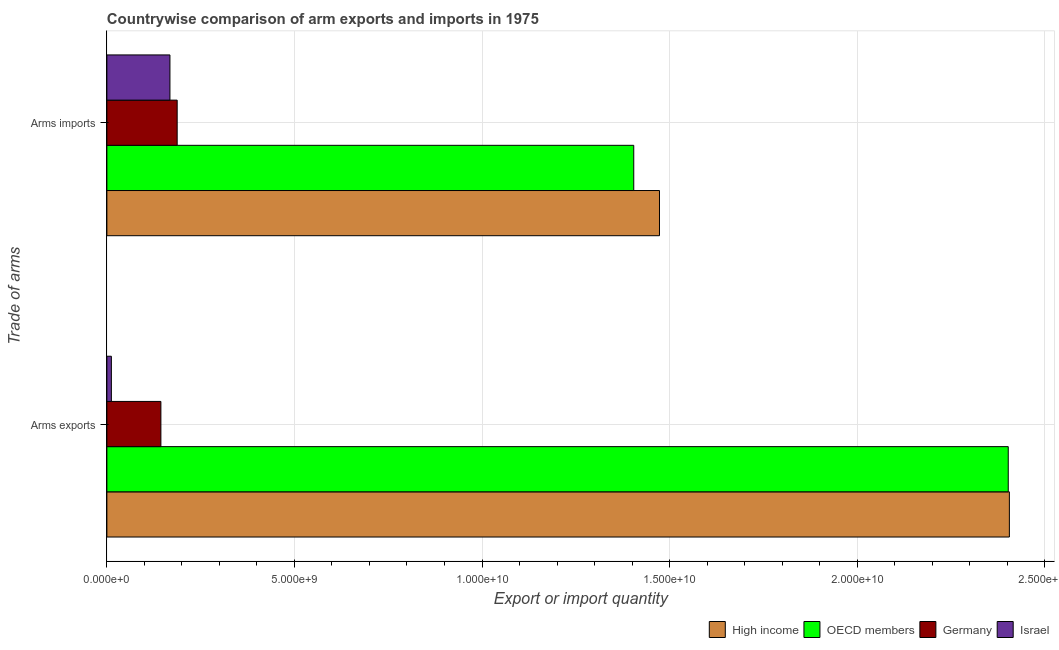How many groups of bars are there?
Offer a terse response. 2. What is the label of the 1st group of bars from the top?
Make the answer very short. Arms imports. What is the arms imports in Israel?
Offer a very short reply. 1.68e+09. Across all countries, what is the maximum arms exports?
Your answer should be compact. 2.41e+1. Across all countries, what is the minimum arms imports?
Offer a terse response. 1.68e+09. What is the total arms imports in the graph?
Your answer should be compact. 3.23e+1. What is the difference between the arms imports in OECD members and that in Israel?
Your answer should be compact. 1.24e+1. What is the difference between the arms exports in Germany and the arms imports in High income?
Ensure brevity in your answer.  -1.33e+1. What is the average arms exports per country?
Offer a terse response. 1.24e+1. What is the difference between the arms exports and arms imports in High income?
Ensure brevity in your answer.  9.33e+09. In how many countries, is the arms exports greater than 9000000000 ?
Provide a succinct answer. 2. What is the ratio of the arms imports in Germany to that in OECD members?
Offer a terse response. 0.13. In how many countries, is the arms exports greater than the average arms exports taken over all countries?
Keep it short and to the point. 2. What does the 2nd bar from the top in Arms imports represents?
Your response must be concise. Germany. How many bars are there?
Ensure brevity in your answer.  8. How many countries are there in the graph?
Your answer should be very brief. 4. Does the graph contain any zero values?
Provide a short and direct response. No. Does the graph contain grids?
Your answer should be very brief. Yes. How many legend labels are there?
Your response must be concise. 4. What is the title of the graph?
Make the answer very short. Countrywise comparison of arm exports and imports in 1975. Does "Moldova" appear as one of the legend labels in the graph?
Offer a very short reply. No. What is the label or title of the X-axis?
Give a very brief answer. Export or import quantity. What is the label or title of the Y-axis?
Provide a short and direct response. Trade of arms. What is the Export or import quantity in High income in Arms exports?
Make the answer very short. 2.41e+1. What is the Export or import quantity in OECD members in Arms exports?
Make the answer very short. 2.40e+1. What is the Export or import quantity in Germany in Arms exports?
Provide a succinct answer. 1.44e+09. What is the Export or import quantity of Israel in Arms exports?
Give a very brief answer. 1.20e+08. What is the Export or import quantity in High income in Arms imports?
Provide a succinct answer. 1.47e+1. What is the Export or import quantity of OECD members in Arms imports?
Provide a short and direct response. 1.40e+1. What is the Export or import quantity of Germany in Arms imports?
Give a very brief answer. 1.87e+09. What is the Export or import quantity in Israel in Arms imports?
Offer a very short reply. 1.68e+09. Across all Trade of arms, what is the maximum Export or import quantity of High income?
Your answer should be compact. 2.41e+1. Across all Trade of arms, what is the maximum Export or import quantity of OECD members?
Offer a very short reply. 2.40e+1. Across all Trade of arms, what is the maximum Export or import quantity of Germany?
Provide a short and direct response. 1.87e+09. Across all Trade of arms, what is the maximum Export or import quantity of Israel?
Ensure brevity in your answer.  1.68e+09. Across all Trade of arms, what is the minimum Export or import quantity of High income?
Offer a terse response. 1.47e+1. Across all Trade of arms, what is the minimum Export or import quantity of OECD members?
Offer a terse response. 1.40e+1. Across all Trade of arms, what is the minimum Export or import quantity in Germany?
Keep it short and to the point. 1.44e+09. Across all Trade of arms, what is the minimum Export or import quantity of Israel?
Offer a very short reply. 1.20e+08. What is the total Export or import quantity in High income in the graph?
Your response must be concise. 3.88e+1. What is the total Export or import quantity in OECD members in the graph?
Ensure brevity in your answer.  3.81e+1. What is the total Export or import quantity of Germany in the graph?
Give a very brief answer. 3.31e+09. What is the total Export or import quantity of Israel in the graph?
Offer a terse response. 1.80e+09. What is the difference between the Export or import quantity in High income in Arms exports and that in Arms imports?
Give a very brief answer. 9.33e+09. What is the difference between the Export or import quantity of OECD members in Arms exports and that in Arms imports?
Your response must be concise. 9.98e+09. What is the difference between the Export or import quantity in Germany in Arms exports and that in Arms imports?
Your answer should be compact. -4.34e+08. What is the difference between the Export or import quantity of Israel in Arms exports and that in Arms imports?
Provide a short and direct response. -1.56e+09. What is the difference between the Export or import quantity of High income in Arms exports and the Export or import quantity of OECD members in Arms imports?
Make the answer very short. 1.00e+1. What is the difference between the Export or import quantity in High income in Arms exports and the Export or import quantity in Germany in Arms imports?
Ensure brevity in your answer.  2.22e+1. What is the difference between the Export or import quantity in High income in Arms exports and the Export or import quantity in Israel in Arms imports?
Your answer should be very brief. 2.24e+1. What is the difference between the Export or import quantity in OECD members in Arms exports and the Export or import quantity in Germany in Arms imports?
Your answer should be very brief. 2.22e+1. What is the difference between the Export or import quantity in OECD members in Arms exports and the Export or import quantity in Israel in Arms imports?
Offer a terse response. 2.23e+1. What is the difference between the Export or import quantity in Germany in Arms exports and the Export or import quantity in Israel in Arms imports?
Make the answer very short. -2.41e+08. What is the average Export or import quantity of High income per Trade of arms?
Offer a very short reply. 1.94e+1. What is the average Export or import quantity in OECD members per Trade of arms?
Make the answer very short. 1.90e+1. What is the average Export or import quantity in Germany per Trade of arms?
Your answer should be compact. 1.66e+09. What is the average Export or import quantity of Israel per Trade of arms?
Offer a very short reply. 9.00e+08. What is the difference between the Export or import quantity of High income and Export or import quantity of OECD members in Arms exports?
Keep it short and to the point. 3.00e+07. What is the difference between the Export or import quantity of High income and Export or import quantity of Germany in Arms exports?
Offer a very short reply. 2.26e+1. What is the difference between the Export or import quantity in High income and Export or import quantity in Israel in Arms exports?
Provide a short and direct response. 2.39e+1. What is the difference between the Export or import quantity in OECD members and Export or import quantity in Germany in Arms exports?
Your answer should be very brief. 2.26e+1. What is the difference between the Export or import quantity of OECD members and Export or import quantity of Israel in Arms exports?
Your answer should be very brief. 2.39e+1. What is the difference between the Export or import quantity of Germany and Export or import quantity of Israel in Arms exports?
Offer a terse response. 1.32e+09. What is the difference between the Export or import quantity of High income and Export or import quantity of OECD members in Arms imports?
Give a very brief answer. 6.86e+08. What is the difference between the Export or import quantity in High income and Export or import quantity in Germany in Arms imports?
Offer a very short reply. 1.29e+1. What is the difference between the Export or import quantity of High income and Export or import quantity of Israel in Arms imports?
Keep it short and to the point. 1.30e+1. What is the difference between the Export or import quantity in OECD members and Export or import quantity in Germany in Arms imports?
Your answer should be very brief. 1.22e+1. What is the difference between the Export or import quantity of OECD members and Export or import quantity of Israel in Arms imports?
Provide a short and direct response. 1.24e+1. What is the difference between the Export or import quantity in Germany and Export or import quantity in Israel in Arms imports?
Your answer should be very brief. 1.93e+08. What is the ratio of the Export or import quantity of High income in Arms exports to that in Arms imports?
Offer a very short reply. 1.63. What is the ratio of the Export or import quantity of OECD members in Arms exports to that in Arms imports?
Your answer should be very brief. 1.71. What is the ratio of the Export or import quantity in Germany in Arms exports to that in Arms imports?
Keep it short and to the point. 0.77. What is the ratio of the Export or import quantity in Israel in Arms exports to that in Arms imports?
Give a very brief answer. 0.07. What is the difference between the highest and the second highest Export or import quantity of High income?
Offer a very short reply. 9.33e+09. What is the difference between the highest and the second highest Export or import quantity of OECD members?
Your response must be concise. 9.98e+09. What is the difference between the highest and the second highest Export or import quantity in Germany?
Your answer should be compact. 4.34e+08. What is the difference between the highest and the second highest Export or import quantity in Israel?
Give a very brief answer. 1.56e+09. What is the difference between the highest and the lowest Export or import quantity of High income?
Make the answer very short. 9.33e+09. What is the difference between the highest and the lowest Export or import quantity in OECD members?
Provide a succinct answer. 9.98e+09. What is the difference between the highest and the lowest Export or import quantity in Germany?
Ensure brevity in your answer.  4.34e+08. What is the difference between the highest and the lowest Export or import quantity in Israel?
Your response must be concise. 1.56e+09. 